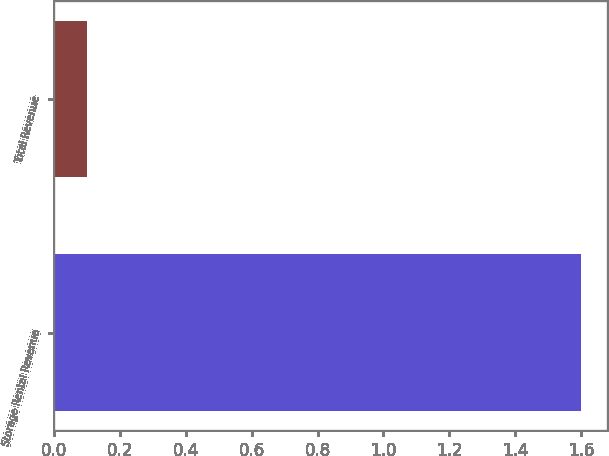<chart> <loc_0><loc_0><loc_500><loc_500><bar_chart><fcel>Storage Rental Revenue<fcel>Total Revenue<nl><fcel>1.6<fcel>0.1<nl></chart> 